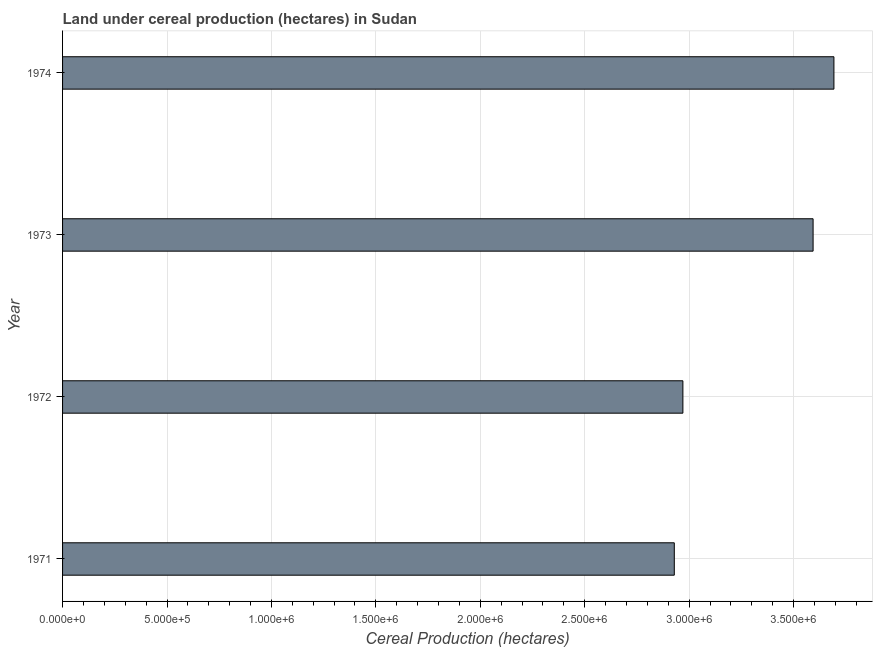What is the title of the graph?
Your response must be concise. Land under cereal production (hectares) in Sudan. What is the label or title of the X-axis?
Your answer should be compact. Cereal Production (hectares). What is the label or title of the Y-axis?
Give a very brief answer. Year. What is the land under cereal production in 1971?
Offer a very short reply. 2.93e+06. Across all years, what is the maximum land under cereal production?
Offer a terse response. 3.69e+06. Across all years, what is the minimum land under cereal production?
Your answer should be very brief. 2.93e+06. In which year was the land under cereal production maximum?
Offer a terse response. 1974. In which year was the land under cereal production minimum?
Make the answer very short. 1971. What is the sum of the land under cereal production?
Your answer should be compact. 1.32e+07. What is the difference between the land under cereal production in 1973 and 1974?
Give a very brief answer. -9.98e+04. What is the average land under cereal production per year?
Your answer should be very brief. 3.30e+06. What is the median land under cereal production?
Your response must be concise. 3.28e+06. In how many years, is the land under cereal production greater than 100000 hectares?
Ensure brevity in your answer.  4. Do a majority of the years between 1972 and 1971 (inclusive) have land under cereal production greater than 2700000 hectares?
Offer a very short reply. No. What is the ratio of the land under cereal production in 1971 to that in 1974?
Ensure brevity in your answer.  0.79. Is the difference between the land under cereal production in 1973 and 1974 greater than the difference between any two years?
Make the answer very short. No. What is the difference between the highest and the second highest land under cereal production?
Provide a succinct answer. 9.98e+04. What is the difference between the highest and the lowest land under cereal production?
Ensure brevity in your answer.  7.64e+05. How many years are there in the graph?
Make the answer very short. 4. What is the difference between two consecutive major ticks on the X-axis?
Offer a terse response. 5.00e+05. What is the Cereal Production (hectares) of 1971?
Provide a short and direct response. 2.93e+06. What is the Cereal Production (hectares) in 1972?
Make the answer very short. 2.97e+06. What is the Cereal Production (hectares) in 1973?
Give a very brief answer. 3.59e+06. What is the Cereal Production (hectares) of 1974?
Provide a short and direct response. 3.69e+06. What is the difference between the Cereal Production (hectares) in 1971 and 1972?
Provide a succinct answer. -4.12e+04. What is the difference between the Cereal Production (hectares) in 1971 and 1973?
Provide a succinct answer. -6.64e+05. What is the difference between the Cereal Production (hectares) in 1971 and 1974?
Provide a succinct answer. -7.64e+05. What is the difference between the Cereal Production (hectares) in 1972 and 1973?
Keep it short and to the point. -6.23e+05. What is the difference between the Cereal Production (hectares) in 1972 and 1974?
Ensure brevity in your answer.  -7.23e+05. What is the difference between the Cereal Production (hectares) in 1973 and 1974?
Your answer should be very brief. -9.98e+04. What is the ratio of the Cereal Production (hectares) in 1971 to that in 1972?
Offer a terse response. 0.99. What is the ratio of the Cereal Production (hectares) in 1971 to that in 1973?
Your answer should be compact. 0.81. What is the ratio of the Cereal Production (hectares) in 1971 to that in 1974?
Offer a terse response. 0.79. What is the ratio of the Cereal Production (hectares) in 1972 to that in 1973?
Your answer should be very brief. 0.83. What is the ratio of the Cereal Production (hectares) in 1972 to that in 1974?
Ensure brevity in your answer.  0.8. 